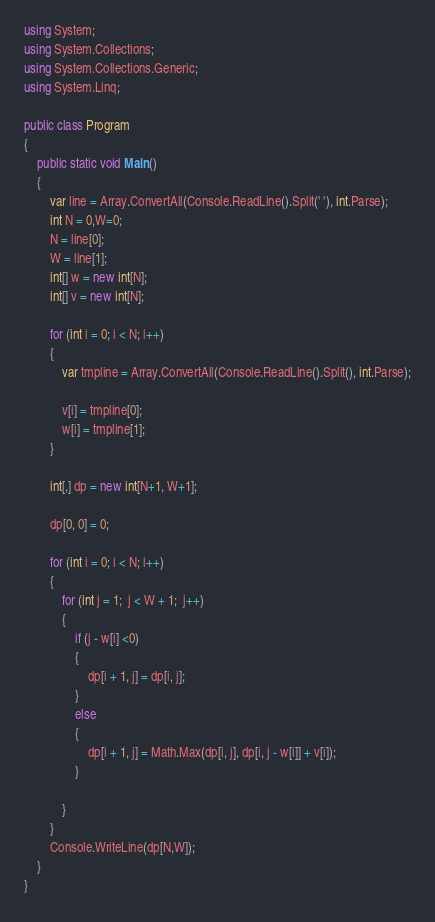Convert code to text. <code><loc_0><loc_0><loc_500><loc_500><_C#_>using System;
using System.Collections;
using System.Collections.Generic;
using System.Linq;

public class Program
{
	public static void Main()
	{
		var line = Array.ConvertAll(Console.ReadLine().Split(' '), int.Parse);
        int N = 0,W=0;
        N = line[0];
        W = line[1];
        int[] w = new int[N];
        int[] v = new int[N];

        for (int i = 0; i < N; i++)
        {
            var tmpline = Array.ConvertAll(Console.ReadLine().Split(), int.Parse);

            v[i] = tmpline[0];
            w[i] = tmpline[1];
        }

        int[,] dp = new int[N+1, W+1];

        dp[0, 0] = 0;

        for (int i = 0; i < N; i++)
        {
            for (int j = 1;  j < W + 1;  j++)
            {
                if (j - w[i] <0)
                {
                    dp[i + 1, j] = dp[i, j];
                }
                else
                {
                    dp[i + 1, j] = Math.Max(dp[i, j], dp[i, j - w[i]] + v[i]);
                }

            }
        }
        Console.WriteLine(dp[N,W]);
	}
}

</code> 